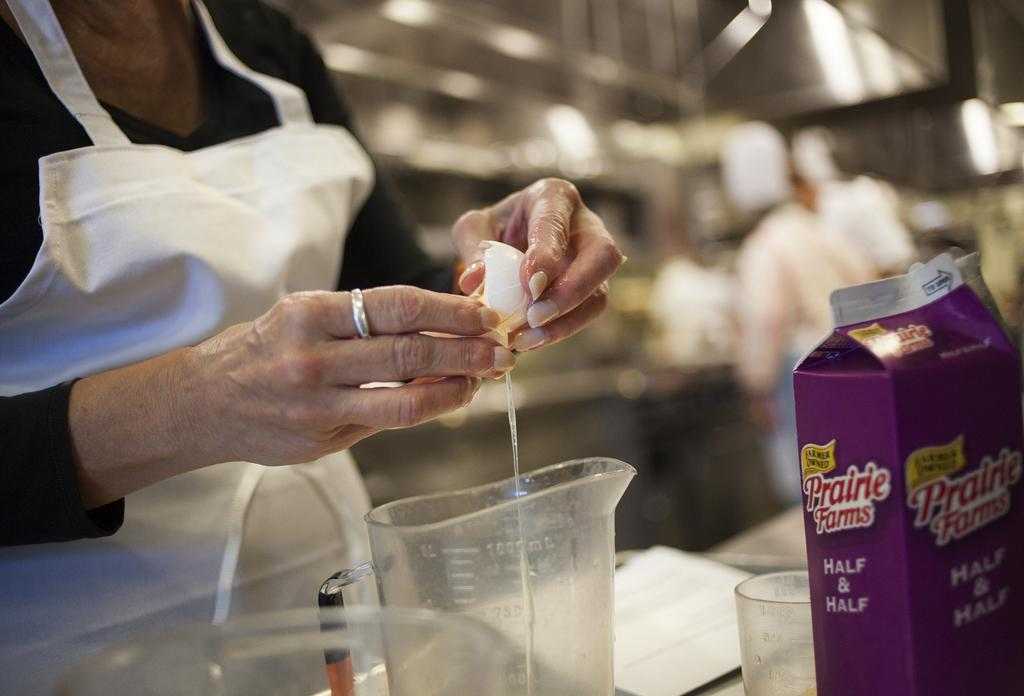<image>
Create a compact narrative representing the image presented. A woman cracks an egg into a measuring cup and a carton of Prairie Farms Half & Half sits on a counter. 